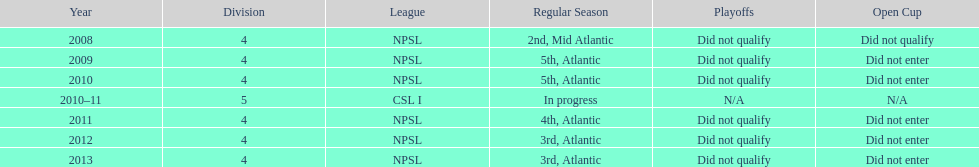In which year did they participate exclusively in division 5? 2010-11. 